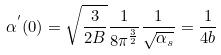Convert formula to latex. <formula><loc_0><loc_0><loc_500><loc_500>\alpha ^ { ^ { \prime } } ( 0 ) = \sqrt { \frac { 3 } { 2 B } } \frac { 1 } { 8 \pi ^ { \frac { 3 } { 2 } } } \frac { 1 } { \sqrt { \alpha _ { s } } } = \frac { 1 } { 4 b }</formula> 